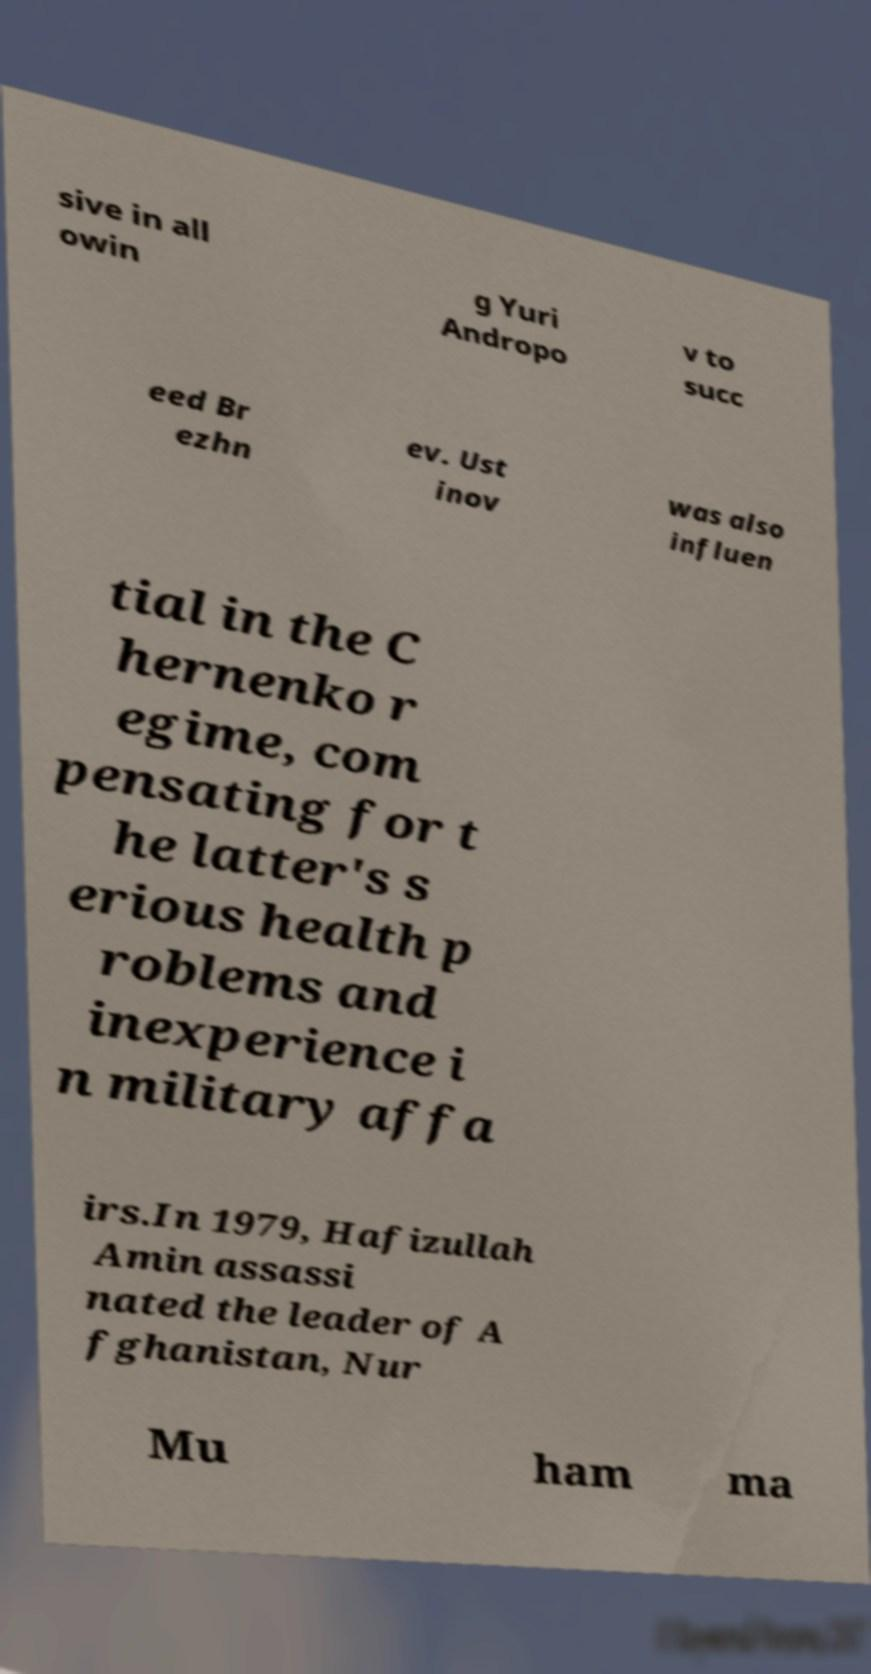Can you read and provide the text displayed in the image?This photo seems to have some interesting text. Can you extract and type it out for me? sive in all owin g Yuri Andropo v to succ eed Br ezhn ev. Ust inov was also influen tial in the C hernenko r egime, com pensating for t he latter's s erious health p roblems and inexperience i n military affa irs.In 1979, Hafizullah Amin assassi nated the leader of A fghanistan, Nur Mu ham ma 